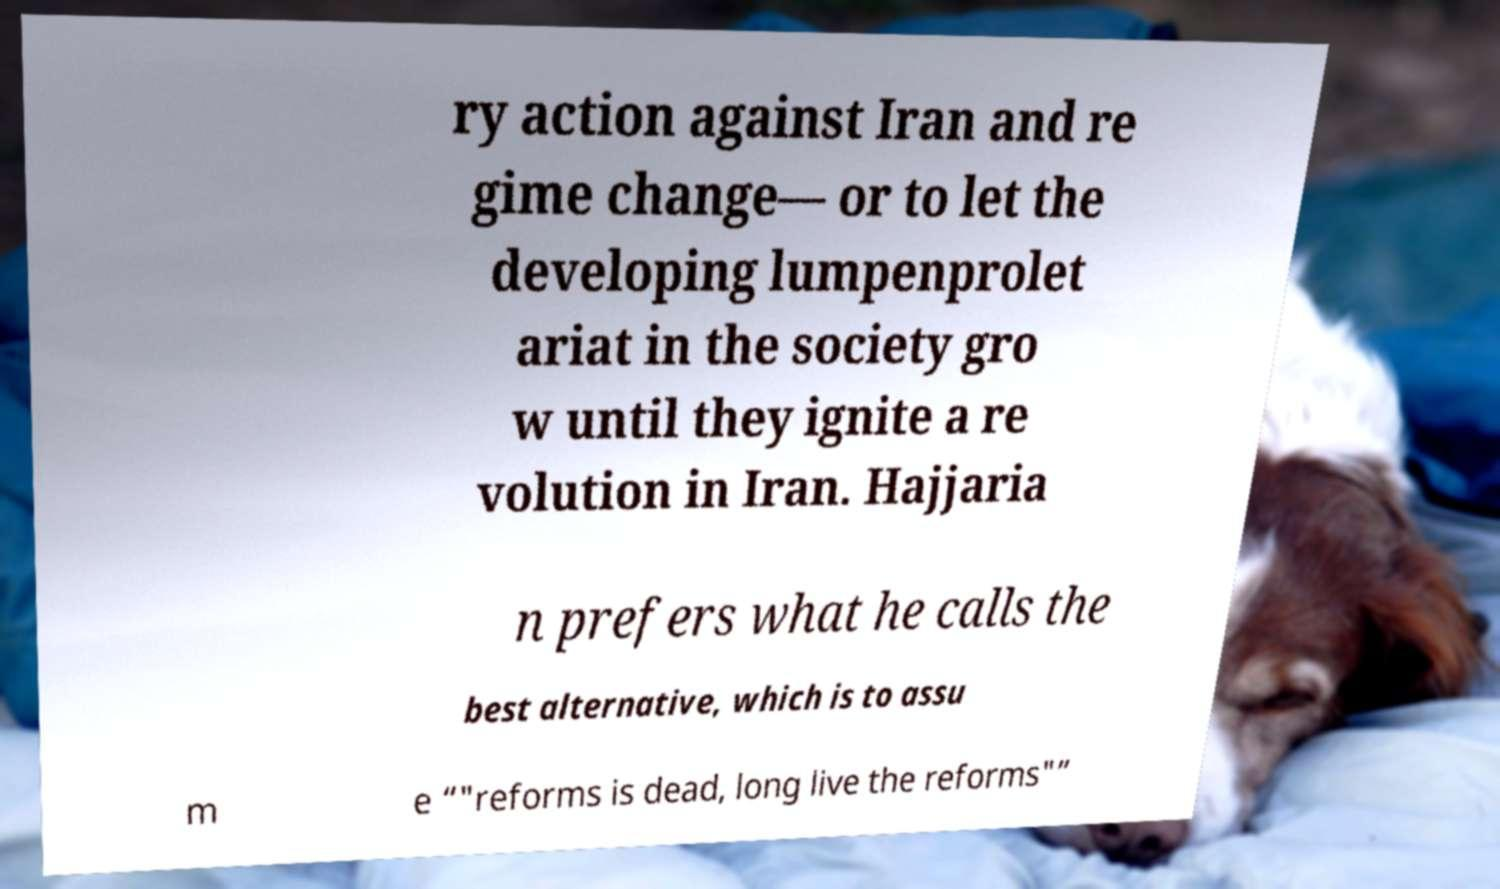Could you assist in decoding the text presented in this image and type it out clearly? ry action against Iran and re gime change— or to let the developing lumpenprolet ariat in the society gro w until they ignite a re volution in Iran. Hajjaria n prefers what he calls the best alternative, which is to assu m e “"reforms is dead, long live the reforms"” 